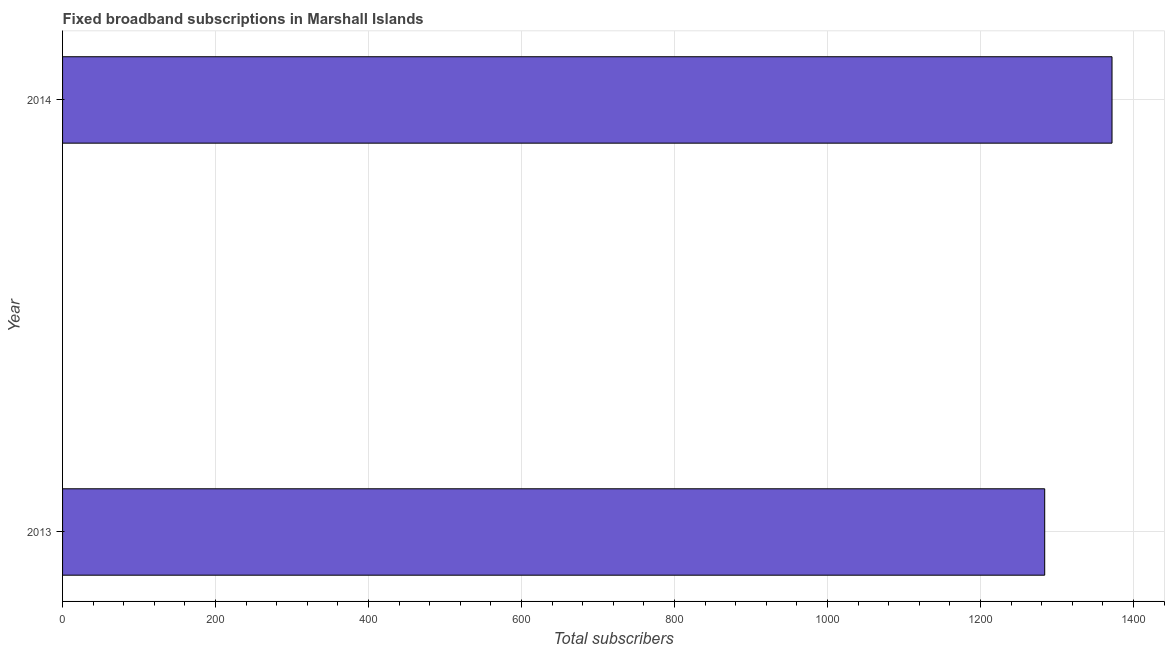Does the graph contain grids?
Offer a very short reply. Yes. What is the title of the graph?
Make the answer very short. Fixed broadband subscriptions in Marshall Islands. What is the label or title of the X-axis?
Offer a terse response. Total subscribers. What is the label or title of the Y-axis?
Keep it short and to the point. Year. What is the total number of fixed broadband subscriptions in 2013?
Make the answer very short. 1284. Across all years, what is the maximum total number of fixed broadband subscriptions?
Keep it short and to the point. 1372. Across all years, what is the minimum total number of fixed broadband subscriptions?
Offer a very short reply. 1284. In which year was the total number of fixed broadband subscriptions maximum?
Provide a short and direct response. 2014. What is the sum of the total number of fixed broadband subscriptions?
Your response must be concise. 2656. What is the difference between the total number of fixed broadband subscriptions in 2013 and 2014?
Give a very brief answer. -88. What is the average total number of fixed broadband subscriptions per year?
Give a very brief answer. 1328. What is the median total number of fixed broadband subscriptions?
Keep it short and to the point. 1328. In how many years, is the total number of fixed broadband subscriptions greater than 1360 ?
Keep it short and to the point. 1. Do a majority of the years between 2014 and 2013 (inclusive) have total number of fixed broadband subscriptions greater than 600 ?
Ensure brevity in your answer.  No. What is the ratio of the total number of fixed broadband subscriptions in 2013 to that in 2014?
Ensure brevity in your answer.  0.94. In how many years, is the total number of fixed broadband subscriptions greater than the average total number of fixed broadband subscriptions taken over all years?
Make the answer very short. 1. How many bars are there?
Provide a succinct answer. 2. What is the difference between two consecutive major ticks on the X-axis?
Offer a very short reply. 200. What is the Total subscribers of 2013?
Ensure brevity in your answer.  1284. What is the Total subscribers of 2014?
Keep it short and to the point. 1372. What is the difference between the Total subscribers in 2013 and 2014?
Offer a very short reply. -88. What is the ratio of the Total subscribers in 2013 to that in 2014?
Your answer should be compact. 0.94. 